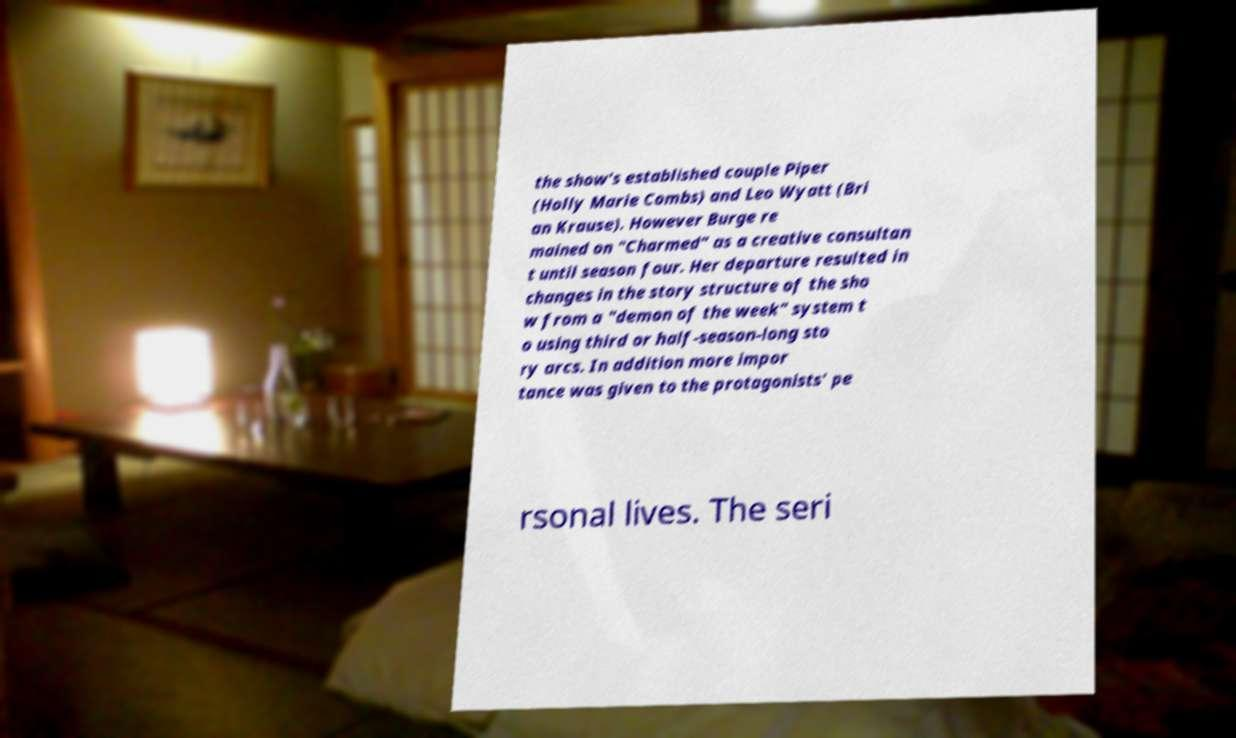Could you extract and type out the text from this image? the show's established couple Piper (Holly Marie Combs) and Leo Wyatt (Bri an Krause). However Burge re mained on "Charmed" as a creative consultan t until season four. Her departure resulted in changes in the story structure of the sho w from a "demon of the week" system t o using third or half-season-long sto ry arcs. In addition more impor tance was given to the protagonists' pe rsonal lives. The seri 